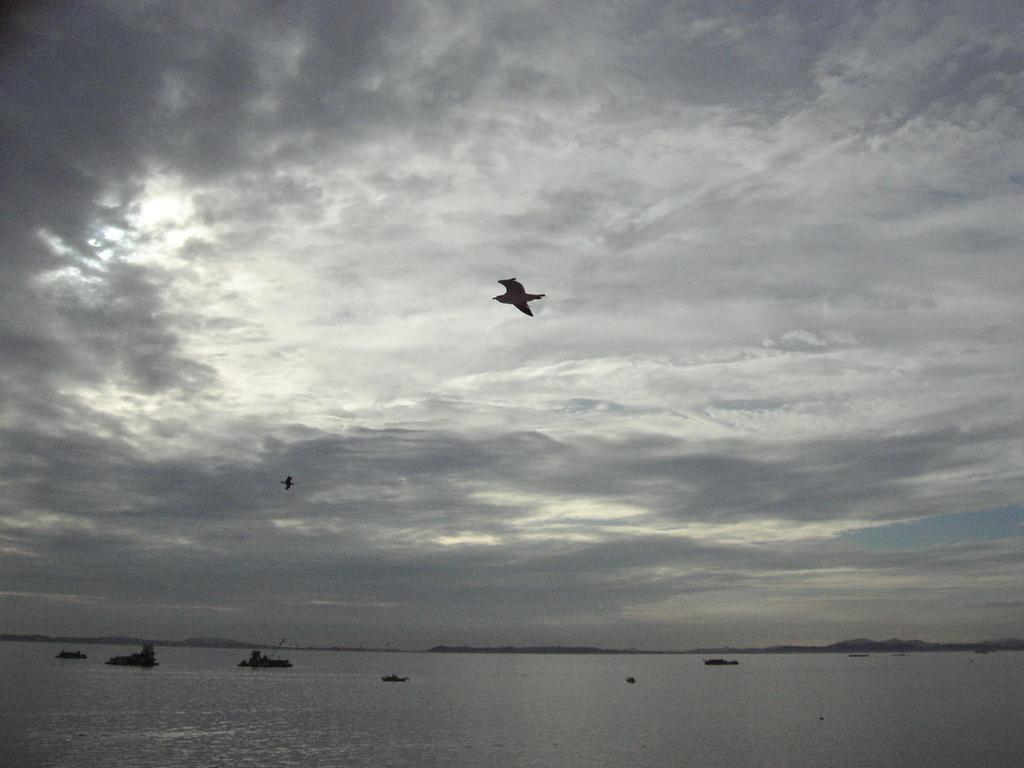What is on the water in the image? There are boats on the water in the image. What else is visible in the sky besides the clouds? The sky is visible in the image. What type of animals can be seen in the image? There are two birds flying in the image. How many children are playing near the boats in the image? There is no mention of children in the image, so we cannot determine the number of children present. Is there a visitor observing the birds in the image? There is no mention of a visitor or any observation activity in the image. 